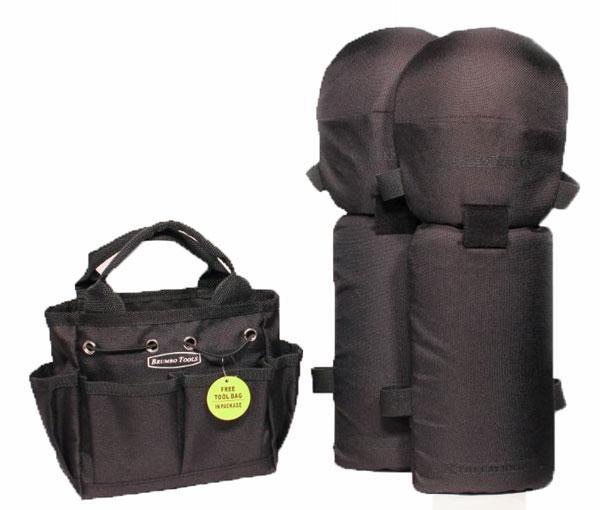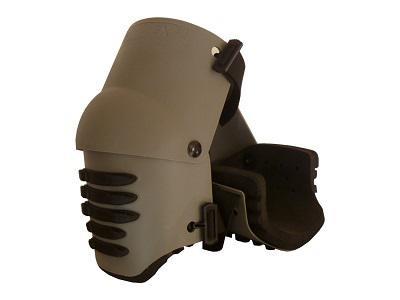The first image is the image on the left, the second image is the image on the right. Given the left and right images, does the statement "There are two charcoal colored knee pads with similar colored straps in the image on the right." hold true? Answer yes or no. No. 